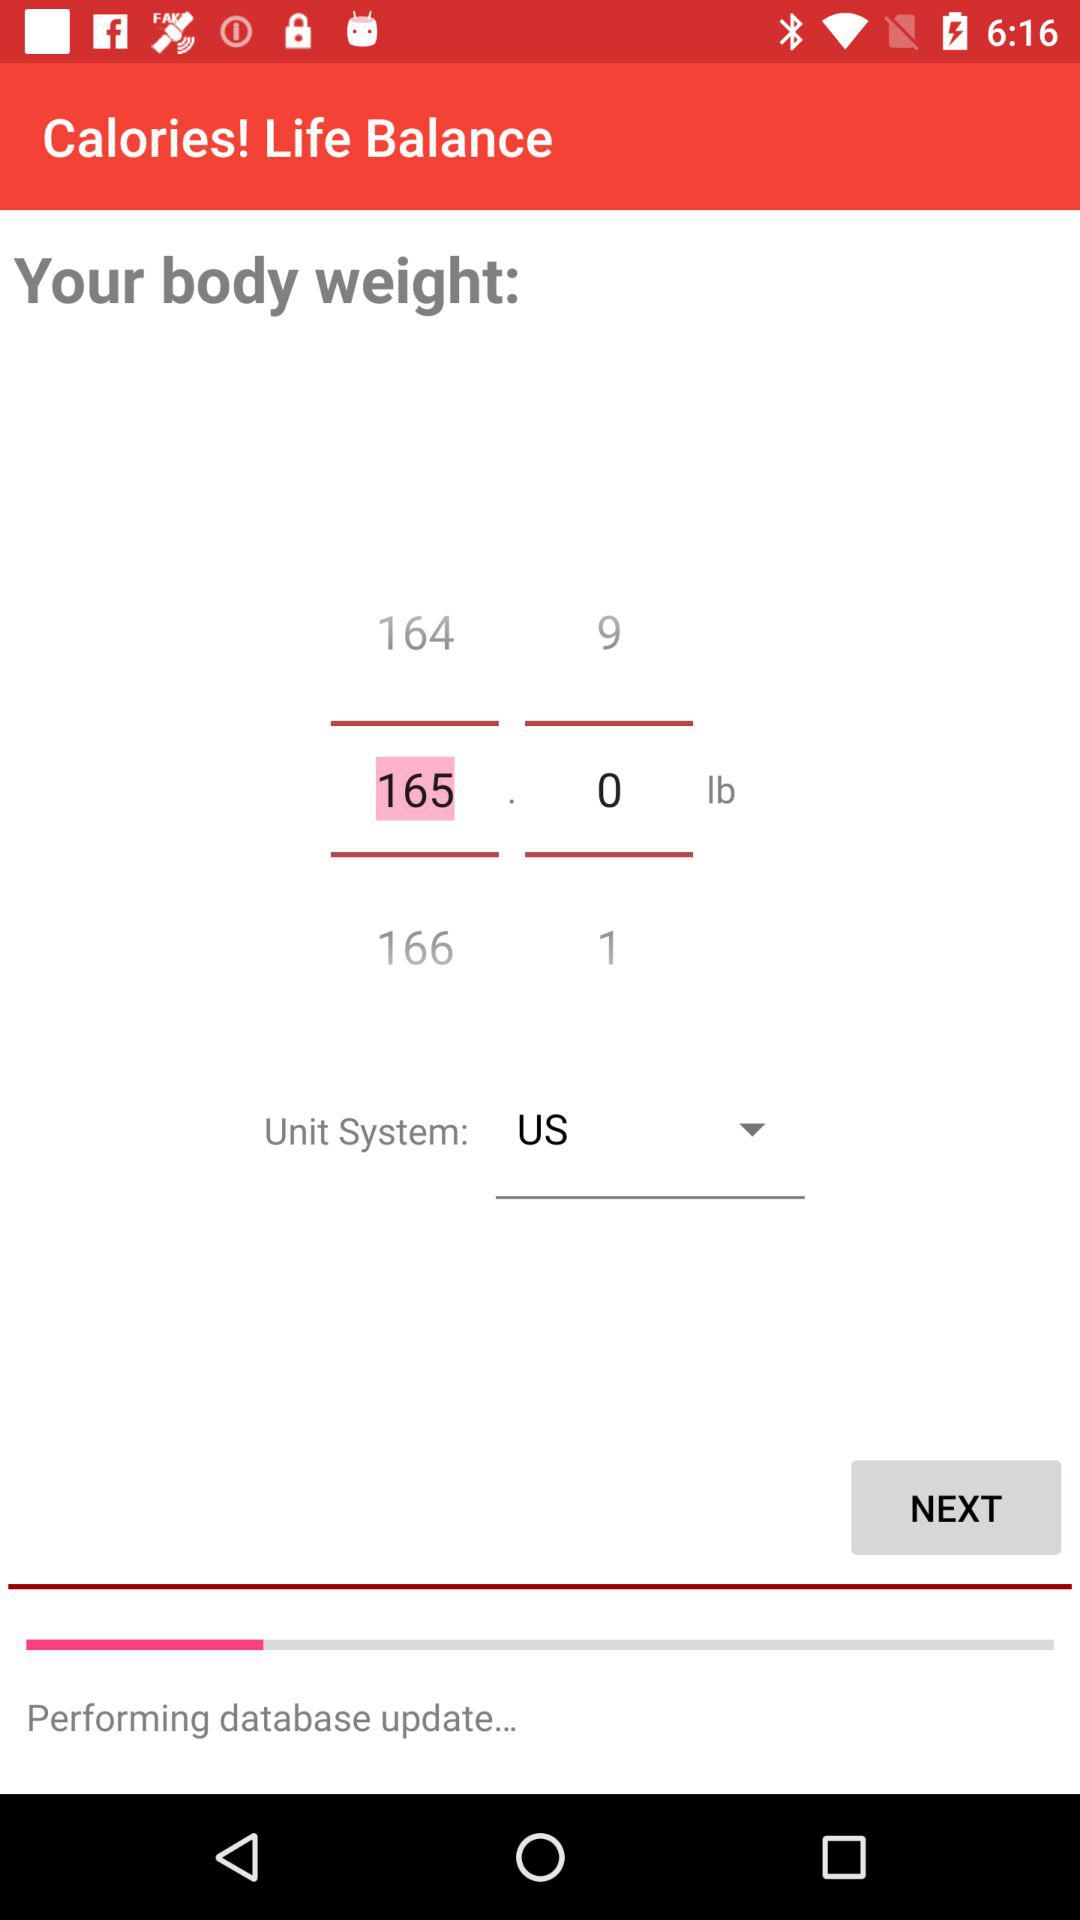What is the weight of the body? The weight of the body is 165.0 lb. 